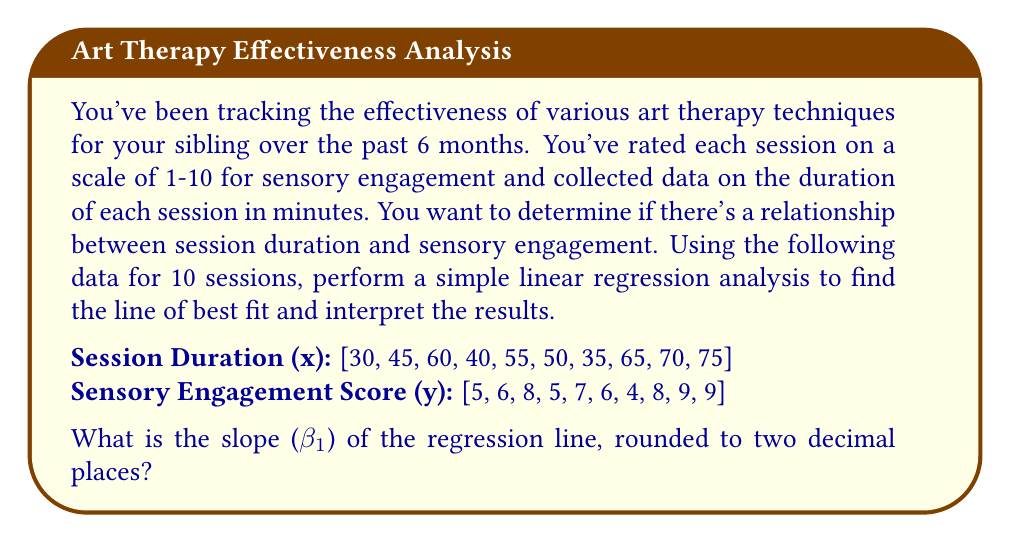Can you answer this question? To perform a simple linear regression analysis and find the line of best fit, we'll use the formula:

$$ y = \beta_0 + \beta_1x $$

Where $\beta_0$ is the y-intercept and $\beta_1$ is the slope.

To calculate the slope $\beta_1$, we'll use the formula:

$$ \beta_1 = \frac{n\sum xy - \sum x \sum y}{n\sum x^2 - (\sum x)^2} $$

Where n is the number of data points.

Step 1: Calculate the necessary sums:
$n = 10$
$\sum x = 525$
$\sum y = 67$
$\sum xy = 3715$
$\sum x^2 = 29,875$

Step 2: Plug these values into the slope formula:

$$ \beta_1 = \frac{10(3715) - 525(67)}{10(29,875) - 525^2} $$

$$ \beta_1 = \frac{37,150 - 35,175}{298,750 - 275,625} $$

$$ \beta_1 = \frac{1,975}{23,125} $$

$$ \beta_1 \approx 0.0854 $$

Rounding to two decimal places, we get $\beta_1 = 0.09$.

Interpretation: The slope of 0.09 indicates that for every 1-minute increase in session duration, the sensory engagement score is expected to increase by 0.09 points on average. This suggests a positive relationship between session duration and sensory engagement, although the effect is relatively small.
Answer: 0.09 